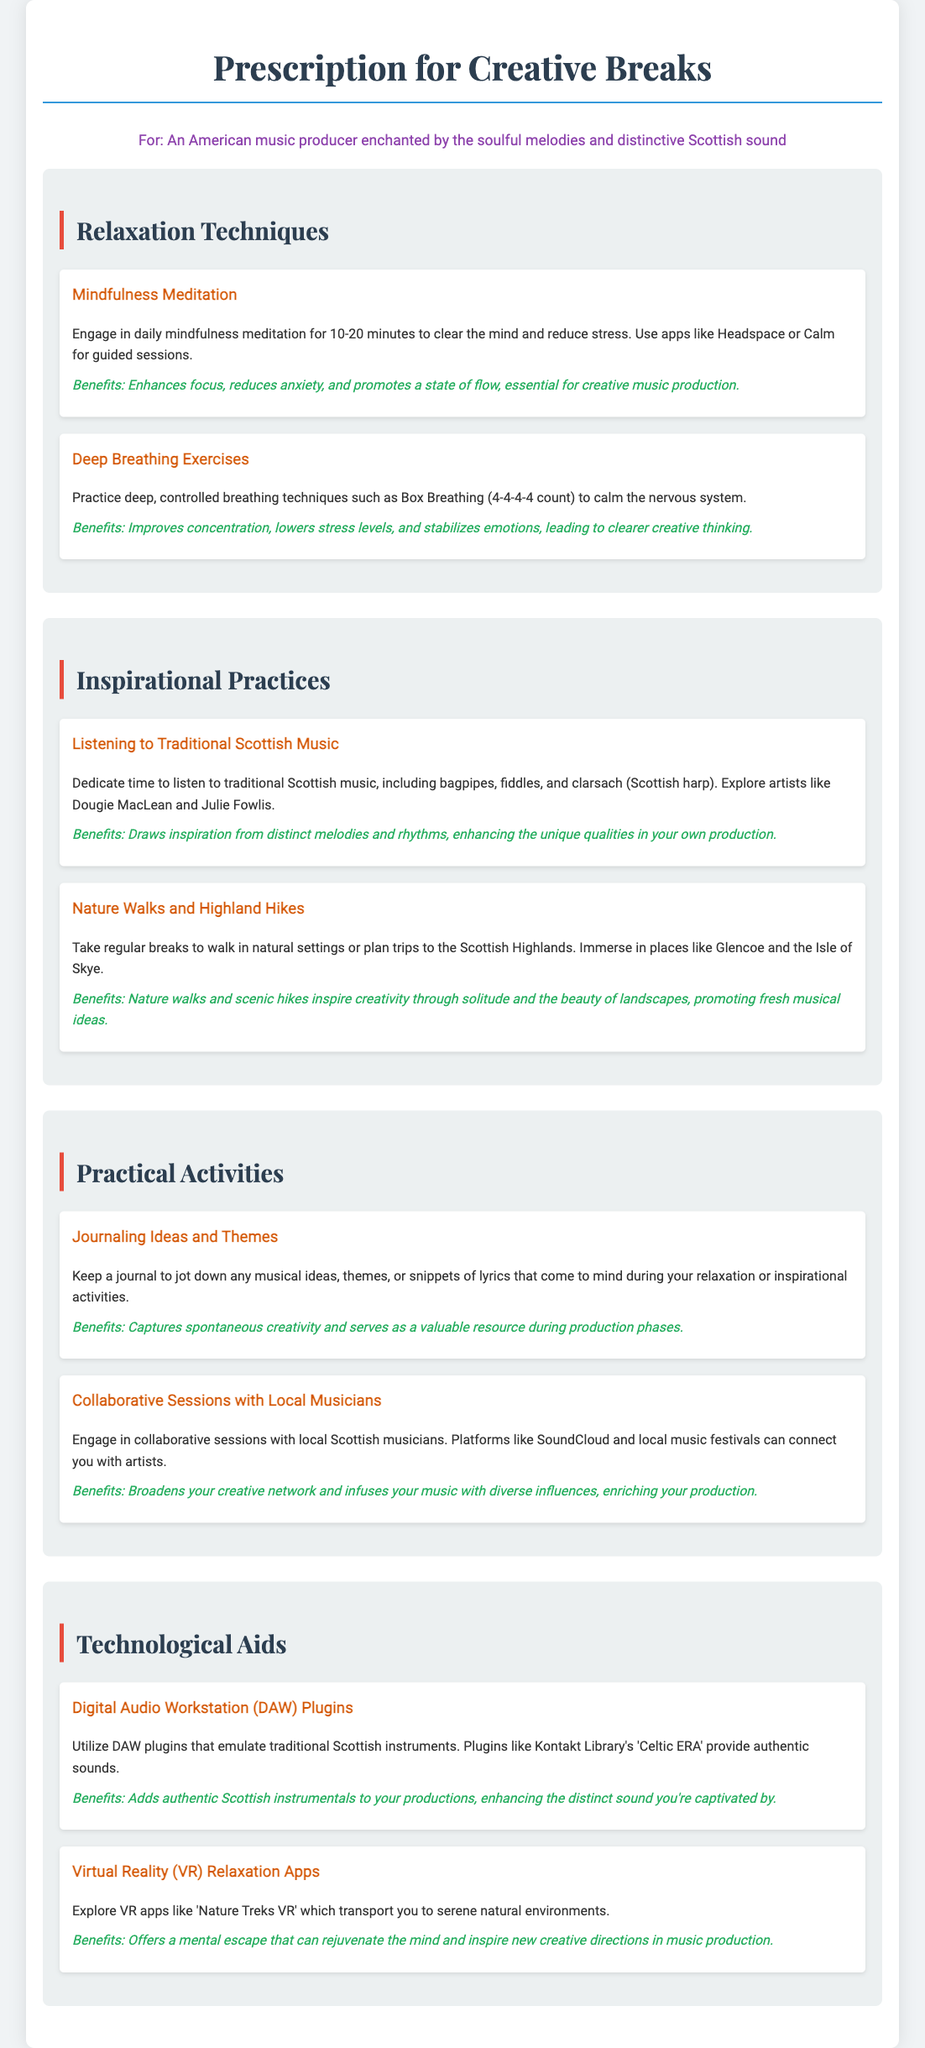What is the title of the document? The title is clearly stated at the top of the document as "Prescription for Creative Breaks."
Answer: Prescription for Creative Breaks How long should daily mindfulness meditation last? It is recommended to engage in daily mindfulness meditation for 10-20 minutes.
Answer: 10-20 minutes What is one traditional Scottish music artist mentioned? The document provides the names of artists such as Dougie MacLean and Julie Fowlis.
Answer: Dougie MacLean What breathing technique is suggested to calm the nervous system? The document mentions Box Breathing as a breathing technique for relaxation.
Answer: Box Breathing What activity should be done while experiencing nature walks? The document suggests immersing in beautiful landscapes found in locations like Glencoe and the Isle of Skye.
Answer: Glencoe and the Isle of Skye What can be used to add authentic Scottish instrumentals to music? The document states that plugins like Kontakt Library's 'Celtic ERA' can be utilized for authentic sounds.
Answer: Kontakt Library's 'Celtic ERA' What type of sessions should be engaged in with local musicians? The document recommends collaborative sessions with local Scottish musicians.
Answer: Collaborative sessions Which VR app is mentioned for relaxation? The document mentions 'Nature Treks VR' as a VR app for relaxation purposes.
Answer: Nature Treks VR 